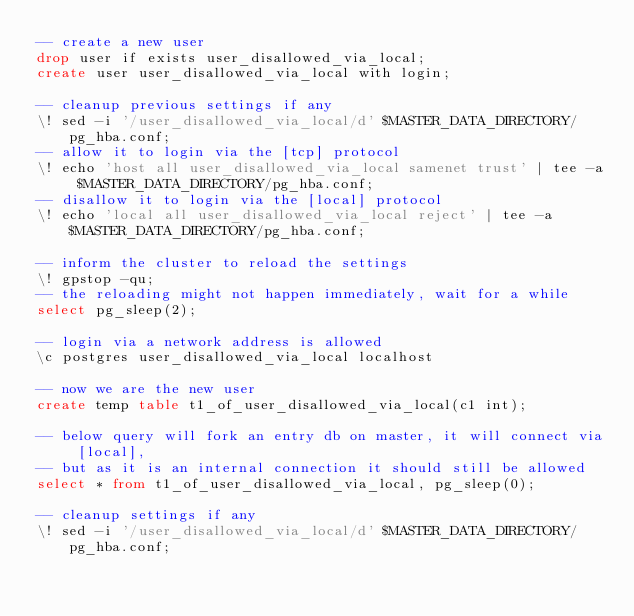Convert code to text. <code><loc_0><loc_0><loc_500><loc_500><_SQL_>-- create a new user
drop user if exists user_disallowed_via_local;
create user user_disallowed_via_local with login;

-- cleanup previous settings if any
\! sed -i '/user_disallowed_via_local/d' $MASTER_DATA_DIRECTORY/pg_hba.conf;
-- allow it to login via the [tcp] protocol
\! echo 'host all user_disallowed_via_local samenet trust' | tee -a $MASTER_DATA_DIRECTORY/pg_hba.conf;
-- disallow it to login via the [local] protocol
\! echo 'local all user_disallowed_via_local reject' | tee -a $MASTER_DATA_DIRECTORY/pg_hba.conf;

-- inform the cluster to reload the settings
\! gpstop -qu;
-- the reloading might not happen immediately, wait for a while
select pg_sleep(2);

-- login via a network address is allowed
\c postgres user_disallowed_via_local localhost

-- now we are the new user
create temp table t1_of_user_disallowed_via_local(c1 int);

-- below query will fork an entry db on master, it will connect via [local],
-- but as it is an internal connection it should still be allowed
select * from t1_of_user_disallowed_via_local, pg_sleep(0);

-- cleanup settings if any
\! sed -i '/user_disallowed_via_local/d' $MASTER_DATA_DIRECTORY/pg_hba.conf;
</code> 